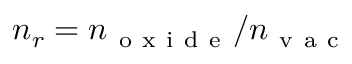Convert formula to latex. <formula><loc_0><loc_0><loc_500><loc_500>n _ { r } = n _ { o x i d e } / n _ { v a c }</formula> 